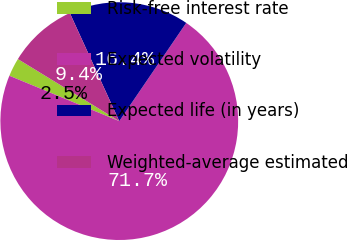<chart> <loc_0><loc_0><loc_500><loc_500><pie_chart><fcel>Risk-free interest rate<fcel>Expected volatility<fcel>Expected life (in years)<fcel>Weighted-average estimated<nl><fcel>2.51%<fcel>71.71%<fcel>16.35%<fcel>9.43%<nl></chart> 